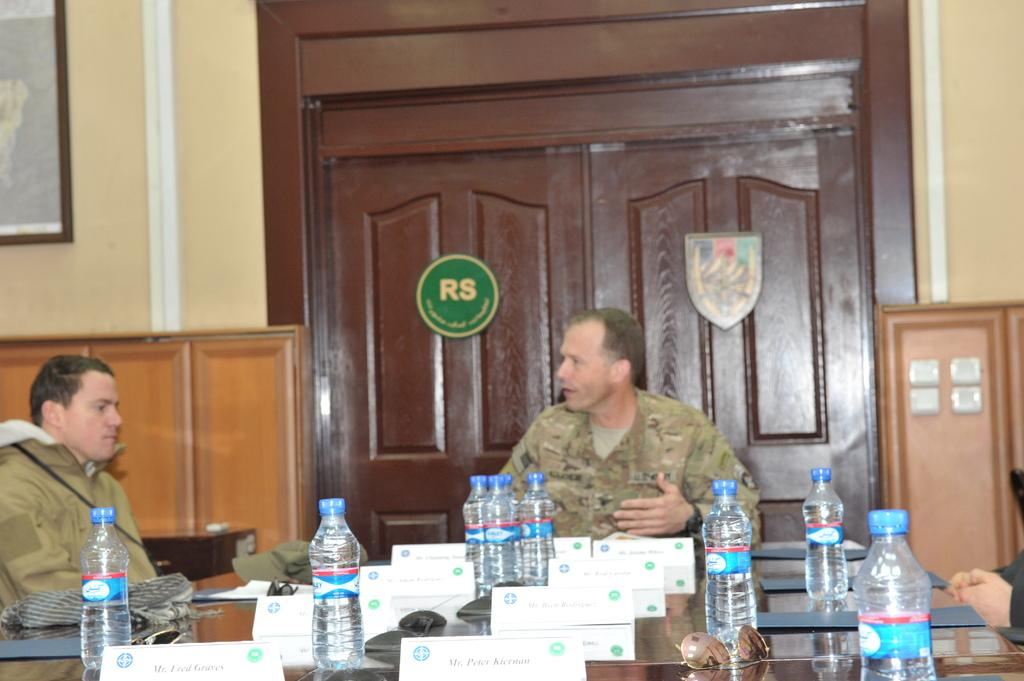How many people are in the image? There are two men in the image. What objects are on the table in the image? There are bottles and a board on the table in the image. What can be seen in the background of the image? There is a door, a wall, a cupboard, and a frame attached to a wall in the background of the image. What type of berry is growing on the wall in the image? There are no berries visible in the image; the frame attached to the wall is the only object mentioned in the background. 